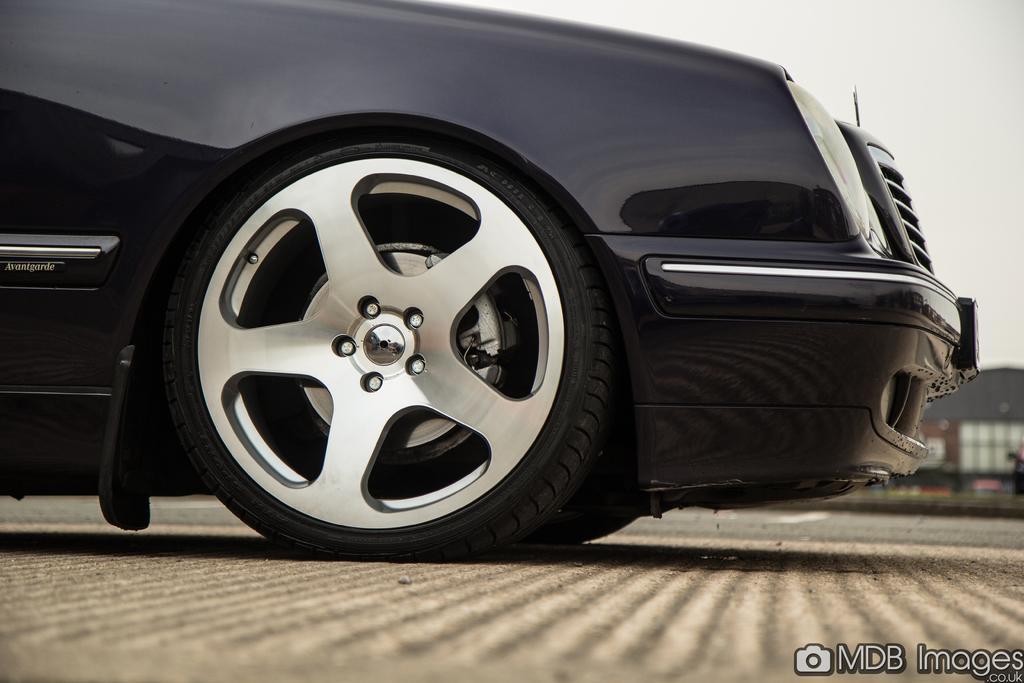Can you describe this image briefly? In this picture we can see a black color car, in the background there is a building, at the right bottom we can see some text, there is the sky at the top of the picture. 